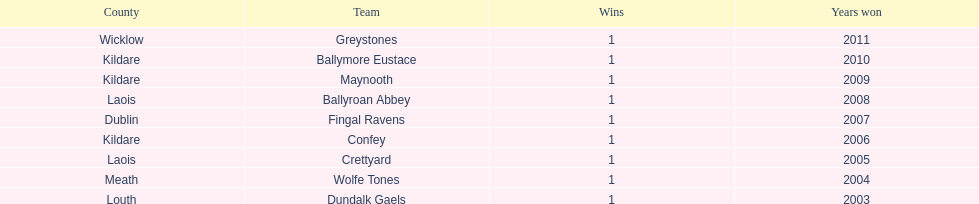How many wins does greystones have? 1. 